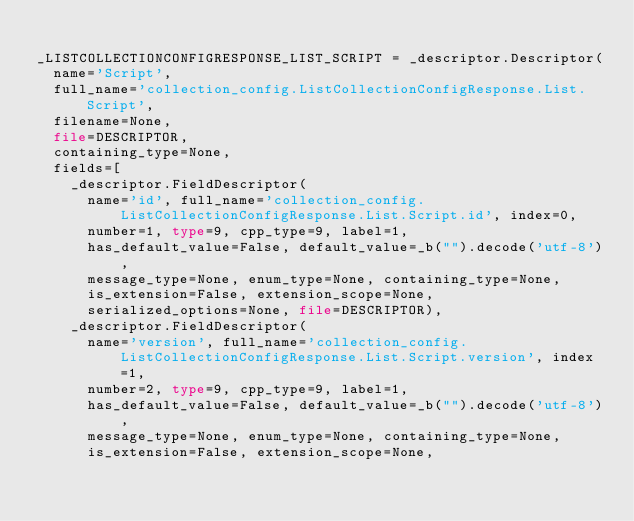Convert code to text. <code><loc_0><loc_0><loc_500><loc_500><_Python_>
_LISTCOLLECTIONCONFIGRESPONSE_LIST_SCRIPT = _descriptor.Descriptor(
  name='Script',
  full_name='collection_config.ListCollectionConfigResponse.List.Script',
  filename=None,
  file=DESCRIPTOR,
  containing_type=None,
  fields=[
    _descriptor.FieldDescriptor(
      name='id', full_name='collection_config.ListCollectionConfigResponse.List.Script.id', index=0,
      number=1, type=9, cpp_type=9, label=1,
      has_default_value=False, default_value=_b("").decode('utf-8'),
      message_type=None, enum_type=None, containing_type=None,
      is_extension=False, extension_scope=None,
      serialized_options=None, file=DESCRIPTOR),
    _descriptor.FieldDescriptor(
      name='version', full_name='collection_config.ListCollectionConfigResponse.List.Script.version', index=1,
      number=2, type=9, cpp_type=9, label=1,
      has_default_value=False, default_value=_b("").decode('utf-8'),
      message_type=None, enum_type=None, containing_type=None,
      is_extension=False, extension_scope=None,</code> 